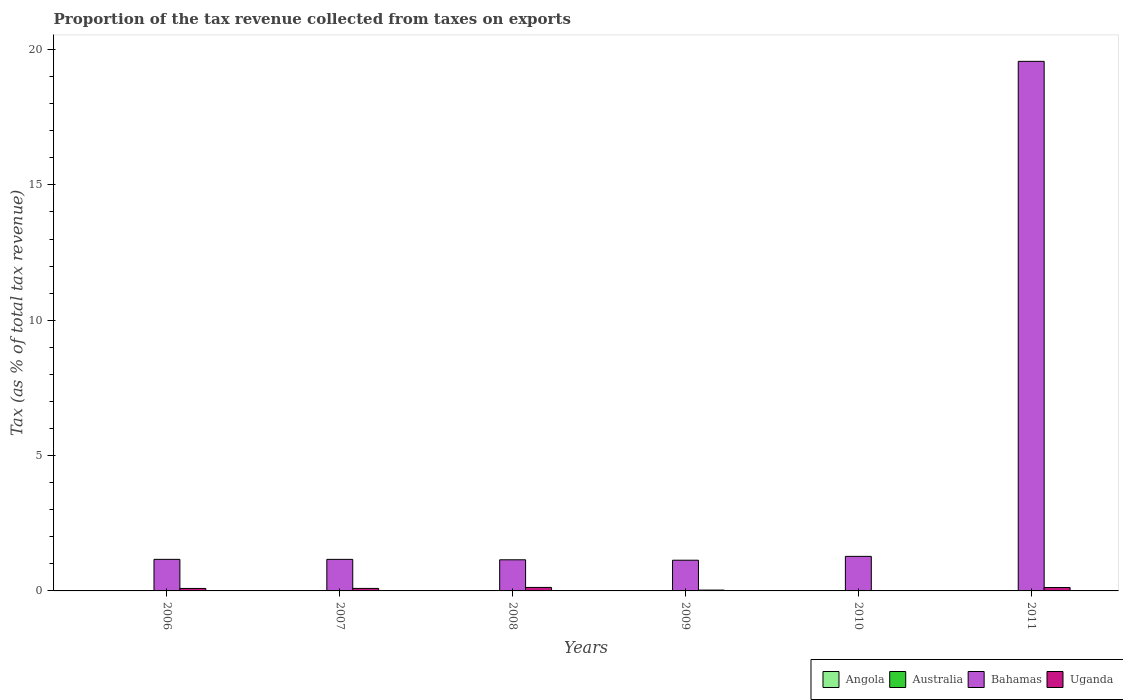Are the number of bars on each tick of the X-axis equal?
Give a very brief answer. Yes. How many bars are there on the 1st tick from the right?
Your answer should be very brief. 4. What is the label of the 3rd group of bars from the left?
Offer a very short reply. 2008. What is the proportion of the tax revenue collected in Bahamas in 2009?
Offer a terse response. 1.13. Across all years, what is the maximum proportion of the tax revenue collected in Angola?
Your response must be concise. 0.01. Across all years, what is the minimum proportion of the tax revenue collected in Angola?
Your answer should be very brief. 0. In which year was the proportion of the tax revenue collected in Uganda maximum?
Keep it short and to the point. 2008. What is the total proportion of the tax revenue collected in Angola in the graph?
Make the answer very short. 0.02. What is the difference between the proportion of the tax revenue collected in Angola in 2010 and that in 2011?
Ensure brevity in your answer.  0. What is the difference between the proportion of the tax revenue collected in Bahamas in 2008 and the proportion of the tax revenue collected in Angola in 2007?
Make the answer very short. 1.14. What is the average proportion of the tax revenue collected in Angola per year?
Your response must be concise. 0. In the year 2009, what is the difference between the proportion of the tax revenue collected in Angola and proportion of the tax revenue collected in Bahamas?
Offer a terse response. -1.13. In how many years, is the proportion of the tax revenue collected in Angola greater than 1 %?
Provide a short and direct response. 0. What is the ratio of the proportion of the tax revenue collected in Australia in 2007 to that in 2009?
Provide a short and direct response. 1.14. Is the proportion of the tax revenue collected in Bahamas in 2010 less than that in 2011?
Offer a very short reply. Yes. What is the difference between the highest and the second highest proportion of the tax revenue collected in Bahamas?
Give a very brief answer. 18.29. What is the difference between the highest and the lowest proportion of the tax revenue collected in Bahamas?
Provide a short and direct response. 18.43. What does the 1st bar from the left in 2010 represents?
Offer a very short reply. Angola. What does the 2nd bar from the right in 2011 represents?
Offer a very short reply. Bahamas. Is it the case that in every year, the sum of the proportion of the tax revenue collected in Uganda and proportion of the tax revenue collected in Australia is greater than the proportion of the tax revenue collected in Angola?
Provide a short and direct response. Yes. Are all the bars in the graph horizontal?
Your answer should be very brief. No. How many years are there in the graph?
Your answer should be compact. 6. What is the difference between two consecutive major ticks on the Y-axis?
Keep it short and to the point. 5. Does the graph contain grids?
Ensure brevity in your answer.  No. Where does the legend appear in the graph?
Provide a short and direct response. Bottom right. How are the legend labels stacked?
Keep it short and to the point. Horizontal. What is the title of the graph?
Keep it short and to the point. Proportion of the tax revenue collected from taxes on exports. What is the label or title of the Y-axis?
Ensure brevity in your answer.  Tax (as % of total tax revenue). What is the Tax (as % of total tax revenue) in Angola in 2006?
Offer a very short reply. 0.01. What is the Tax (as % of total tax revenue) of Australia in 2006?
Your answer should be compact. 0.01. What is the Tax (as % of total tax revenue) of Bahamas in 2006?
Give a very brief answer. 1.17. What is the Tax (as % of total tax revenue) in Uganda in 2006?
Give a very brief answer. 0.09. What is the Tax (as % of total tax revenue) of Angola in 2007?
Ensure brevity in your answer.  0.01. What is the Tax (as % of total tax revenue) in Australia in 2007?
Provide a short and direct response. 0.01. What is the Tax (as % of total tax revenue) in Bahamas in 2007?
Give a very brief answer. 1.17. What is the Tax (as % of total tax revenue) of Uganda in 2007?
Provide a short and direct response. 0.09. What is the Tax (as % of total tax revenue) in Angola in 2008?
Keep it short and to the point. 0. What is the Tax (as % of total tax revenue) in Australia in 2008?
Keep it short and to the point. 0. What is the Tax (as % of total tax revenue) in Bahamas in 2008?
Your response must be concise. 1.15. What is the Tax (as % of total tax revenue) of Uganda in 2008?
Keep it short and to the point. 0.13. What is the Tax (as % of total tax revenue) of Angola in 2009?
Provide a short and direct response. 0. What is the Tax (as % of total tax revenue) of Australia in 2009?
Keep it short and to the point. 0. What is the Tax (as % of total tax revenue) in Bahamas in 2009?
Provide a short and direct response. 1.13. What is the Tax (as % of total tax revenue) of Uganda in 2009?
Give a very brief answer. 0.03. What is the Tax (as % of total tax revenue) of Angola in 2010?
Offer a very short reply. 0. What is the Tax (as % of total tax revenue) of Australia in 2010?
Give a very brief answer. 0.01. What is the Tax (as % of total tax revenue) in Bahamas in 2010?
Provide a succinct answer. 1.28. What is the Tax (as % of total tax revenue) of Uganda in 2010?
Provide a succinct answer. 0. What is the Tax (as % of total tax revenue) in Angola in 2011?
Provide a short and direct response. 0. What is the Tax (as % of total tax revenue) in Australia in 2011?
Provide a succinct answer. 0. What is the Tax (as % of total tax revenue) of Bahamas in 2011?
Keep it short and to the point. 19.56. What is the Tax (as % of total tax revenue) in Uganda in 2011?
Provide a short and direct response. 0.13. Across all years, what is the maximum Tax (as % of total tax revenue) of Angola?
Your answer should be compact. 0.01. Across all years, what is the maximum Tax (as % of total tax revenue) in Australia?
Your response must be concise. 0.01. Across all years, what is the maximum Tax (as % of total tax revenue) in Bahamas?
Give a very brief answer. 19.56. Across all years, what is the maximum Tax (as % of total tax revenue) in Uganda?
Offer a terse response. 0.13. Across all years, what is the minimum Tax (as % of total tax revenue) in Angola?
Give a very brief answer. 0. Across all years, what is the minimum Tax (as % of total tax revenue) in Australia?
Provide a short and direct response. 0. Across all years, what is the minimum Tax (as % of total tax revenue) of Bahamas?
Make the answer very short. 1.13. Across all years, what is the minimum Tax (as % of total tax revenue) in Uganda?
Offer a terse response. 0. What is the total Tax (as % of total tax revenue) in Angola in the graph?
Your answer should be very brief. 0.02. What is the total Tax (as % of total tax revenue) of Australia in the graph?
Give a very brief answer. 0.03. What is the total Tax (as % of total tax revenue) of Bahamas in the graph?
Your response must be concise. 25.46. What is the total Tax (as % of total tax revenue) in Uganda in the graph?
Offer a terse response. 0.47. What is the difference between the Tax (as % of total tax revenue) in Angola in 2006 and that in 2007?
Offer a very short reply. 0. What is the difference between the Tax (as % of total tax revenue) in Uganda in 2006 and that in 2007?
Offer a very short reply. -0. What is the difference between the Tax (as % of total tax revenue) of Angola in 2006 and that in 2008?
Ensure brevity in your answer.  0.01. What is the difference between the Tax (as % of total tax revenue) in Australia in 2006 and that in 2008?
Your response must be concise. 0. What is the difference between the Tax (as % of total tax revenue) in Bahamas in 2006 and that in 2008?
Your answer should be very brief. 0.02. What is the difference between the Tax (as % of total tax revenue) in Uganda in 2006 and that in 2008?
Offer a very short reply. -0.04. What is the difference between the Tax (as % of total tax revenue) of Angola in 2006 and that in 2009?
Make the answer very short. 0.01. What is the difference between the Tax (as % of total tax revenue) in Australia in 2006 and that in 2009?
Offer a terse response. 0. What is the difference between the Tax (as % of total tax revenue) in Bahamas in 2006 and that in 2009?
Your answer should be compact. 0.03. What is the difference between the Tax (as % of total tax revenue) of Uganda in 2006 and that in 2009?
Your answer should be very brief. 0.06. What is the difference between the Tax (as % of total tax revenue) in Angola in 2006 and that in 2010?
Your answer should be very brief. 0.01. What is the difference between the Tax (as % of total tax revenue) in Bahamas in 2006 and that in 2010?
Offer a very short reply. -0.11. What is the difference between the Tax (as % of total tax revenue) of Uganda in 2006 and that in 2010?
Provide a succinct answer. 0.09. What is the difference between the Tax (as % of total tax revenue) in Angola in 2006 and that in 2011?
Keep it short and to the point. 0.01. What is the difference between the Tax (as % of total tax revenue) of Australia in 2006 and that in 2011?
Provide a succinct answer. 0. What is the difference between the Tax (as % of total tax revenue) in Bahamas in 2006 and that in 2011?
Your response must be concise. -18.4. What is the difference between the Tax (as % of total tax revenue) of Uganda in 2006 and that in 2011?
Provide a short and direct response. -0.03. What is the difference between the Tax (as % of total tax revenue) in Angola in 2007 and that in 2008?
Your response must be concise. 0.01. What is the difference between the Tax (as % of total tax revenue) of Australia in 2007 and that in 2008?
Your response must be concise. 0. What is the difference between the Tax (as % of total tax revenue) in Bahamas in 2007 and that in 2008?
Make the answer very short. 0.02. What is the difference between the Tax (as % of total tax revenue) of Uganda in 2007 and that in 2008?
Your answer should be compact. -0.04. What is the difference between the Tax (as % of total tax revenue) of Angola in 2007 and that in 2009?
Make the answer very short. 0.01. What is the difference between the Tax (as % of total tax revenue) of Australia in 2007 and that in 2009?
Give a very brief answer. 0. What is the difference between the Tax (as % of total tax revenue) of Bahamas in 2007 and that in 2009?
Your answer should be very brief. 0.03. What is the difference between the Tax (as % of total tax revenue) of Uganda in 2007 and that in 2009?
Provide a short and direct response. 0.06. What is the difference between the Tax (as % of total tax revenue) of Angola in 2007 and that in 2010?
Give a very brief answer. 0.01. What is the difference between the Tax (as % of total tax revenue) in Bahamas in 2007 and that in 2010?
Ensure brevity in your answer.  -0.11. What is the difference between the Tax (as % of total tax revenue) in Uganda in 2007 and that in 2010?
Your answer should be compact. 0.09. What is the difference between the Tax (as % of total tax revenue) of Angola in 2007 and that in 2011?
Give a very brief answer. 0.01. What is the difference between the Tax (as % of total tax revenue) of Australia in 2007 and that in 2011?
Your response must be concise. 0. What is the difference between the Tax (as % of total tax revenue) of Bahamas in 2007 and that in 2011?
Make the answer very short. -18.4. What is the difference between the Tax (as % of total tax revenue) in Uganda in 2007 and that in 2011?
Make the answer very short. -0.03. What is the difference between the Tax (as % of total tax revenue) in Angola in 2008 and that in 2009?
Offer a terse response. -0. What is the difference between the Tax (as % of total tax revenue) in Australia in 2008 and that in 2009?
Make the answer very short. -0. What is the difference between the Tax (as % of total tax revenue) in Bahamas in 2008 and that in 2009?
Your response must be concise. 0.02. What is the difference between the Tax (as % of total tax revenue) of Uganda in 2008 and that in 2009?
Provide a succinct answer. 0.1. What is the difference between the Tax (as % of total tax revenue) of Angola in 2008 and that in 2010?
Offer a terse response. -0. What is the difference between the Tax (as % of total tax revenue) of Australia in 2008 and that in 2010?
Make the answer very short. -0. What is the difference between the Tax (as % of total tax revenue) in Bahamas in 2008 and that in 2010?
Offer a very short reply. -0.13. What is the difference between the Tax (as % of total tax revenue) in Uganda in 2008 and that in 2010?
Provide a short and direct response. 0.13. What is the difference between the Tax (as % of total tax revenue) of Angola in 2008 and that in 2011?
Ensure brevity in your answer.  -0. What is the difference between the Tax (as % of total tax revenue) in Australia in 2008 and that in 2011?
Offer a very short reply. -0. What is the difference between the Tax (as % of total tax revenue) in Bahamas in 2008 and that in 2011?
Offer a terse response. -18.41. What is the difference between the Tax (as % of total tax revenue) in Uganda in 2008 and that in 2011?
Your response must be concise. 0. What is the difference between the Tax (as % of total tax revenue) of Angola in 2009 and that in 2010?
Your response must be concise. -0. What is the difference between the Tax (as % of total tax revenue) in Australia in 2009 and that in 2010?
Keep it short and to the point. -0. What is the difference between the Tax (as % of total tax revenue) in Bahamas in 2009 and that in 2010?
Provide a short and direct response. -0.14. What is the difference between the Tax (as % of total tax revenue) of Uganda in 2009 and that in 2010?
Your answer should be compact. 0.03. What is the difference between the Tax (as % of total tax revenue) in Angola in 2009 and that in 2011?
Make the answer very short. 0. What is the difference between the Tax (as % of total tax revenue) of Australia in 2009 and that in 2011?
Offer a terse response. 0. What is the difference between the Tax (as % of total tax revenue) of Bahamas in 2009 and that in 2011?
Ensure brevity in your answer.  -18.43. What is the difference between the Tax (as % of total tax revenue) of Uganda in 2009 and that in 2011?
Your answer should be compact. -0.09. What is the difference between the Tax (as % of total tax revenue) of Australia in 2010 and that in 2011?
Your answer should be very brief. 0. What is the difference between the Tax (as % of total tax revenue) of Bahamas in 2010 and that in 2011?
Give a very brief answer. -18.29. What is the difference between the Tax (as % of total tax revenue) in Uganda in 2010 and that in 2011?
Ensure brevity in your answer.  -0.12. What is the difference between the Tax (as % of total tax revenue) in Angola in 2006 and the Tax (as % of total tax revenue) in Australia in 2007?
Provide a short and direct response. 0. What is the difference between the Tax (as % of total tax revenue) in Angola in 2006 and the Tax (as % of total tax revenue) in Bahamas in 2007?
Make the answer very short. -1.16. What is the difference between the Tax (as % of total tax revenue) of Angola in 2006 and the Tax (as % of total tax revenue) of Uganda in 2007?
Provide a short and direct response. -0.09. What is the difference between the Tax (as % of total tax revenue) in Australia in 2006 and the Tax (as % of total tax revenue) in Bahamas in 2007?
Keep it short and to the point. -1.16. What is the difference between the Tax (as % of total tax revenue) in Australia in 2006 and the Tax (as % of total tax revenue) in Uganda in 2007?
Your response must be concise. -0.09. What is the difference between the Tax (as % of total tax revenue) of Bahamas in 2006 and the Tax (as % of total tax revenue) of Uganda in 2007?
Provide a succinct answer. 1.07. What is the difference between the Tax (as % of total tax revenue) of Angola in 2006 and the Tax (as % of total tax revenue) of Australia in 2008?
Keep it short and to the point. 0. What is the difference between the Tax (as % of total tax revenue) in Angola in 2006 and the Tax (as % of total tax revenue) in Bahamas in 2008?
Provide a succinct answer. -1.14. What is the difference between the Tax (as % of total tax revenue) of Angola in 2006 and the Tax (as % of total tax revenue) of Uganda in 2008?
Your answer should be compact. -0.12. What is the difference between the Tax (as % of total tax revenue) in Australia in 2006 and the Tax (as % of total tax revenue) in Bahamas in 2008?
Your answer should be very brief. -1.14. What is the difference between the Tax (as % of total tax revenue) in Australia in 2006 and the Tax (as % of total tax revenue) in Uganda in 2008?
Offer a terse response. -0.12. What is the difference between the Tax (as % of total tax revenue) of Bahamas in 2006 and the Tax (as % of total tax revenue) of Uganda in 2008?
Keep it short and to the point. 1.04. What is the difference between the Tax (as % of total tax revenue) of Angola in 2006 and the Tax (as % of total tax revenue) of Australia in 2009?
Provide a short and direct response. 0. What is the difference between the Tax (as % of total tax revenue) of Angola in 2006 and the Tax (as % of total tax revenue) of Bahamas in 2009?
Provide a succinct answer. -1.13. What is the difference between the Tax (as % of total tax revenue) of Angola in 2006 and the Tax (as % of total tax revenue) of Uganda in 2009?
Offer a very short reply. -0.02. What is the difference between the Tax (as % of total tax revenue) in Australia in 2006 and the Tax (as % of total tax revenue) in Bahamas in 2009?
Provide a succinct answer. -1.13. What is the difference between the Tax (as % of total tax revenue) of Australia in 2006 and the Tax (as % of total tax revenue) of Uganda in 2009?
Your answer should be compact. -0.03. What is the difference between the Tax (as % of total tax revenue) of Bahamas in 2006 and the Tax (as % of total tax revenue) of Uganda in 2009?
Your answer should be very brief. 1.14. What is the difference between the Tax (as % of total tax revenue) in Angola in 2006 and the Tax (as % of total tax revenue) in Australia in 2010?
Make the answer very short. 0. What is the difference between the Tax (as % of total tax revenue) in Angola in 2006 and the Tax (as % of total tax revenue) in Bahamas in 2010?
Keep it short and to the point. -1.27. What is the difference between the Tax (as % of total tax revenue) of Angola in 2006 and the Tax (as % of total tax revenue) of Uganda in 2010?
Your response must be concise. 0. What is the difference between the Tax (as % of total tax revenue) of Australia in 2006 and the Tax (as % of total tax revenue) of Bahamas in 2010?
Offer a terse response. -1.27. What is the difference between the Tax (as % of total tax revenue) in Australia in 2006 and the Tax (as % of total tax revenue) in Uganda in 2010?
Your answer should be very brief. 0. What is the difference between the Tax (as % of total tax revenue) in Bahamas in 2006 and the Tax (as % of total tax revenue) in Uganda in 2010?
Your answer should be very brief. 1.16. What is the difference between the Tax (as % of total tax revenue) of Angola in 2006 and the Tax (as % of total tax revenue) of Australia in 2011?
Offer a very short reply. 0. What is the difference between the Tax (as % of total tax revenue) of Angola in 2006 and the Tax (as % of total tax revenue) of Bahamas in 2011?
Offer a terse response. -19.56. What is the difference between the Tax (as % of total tax revenue) in Angola in 2006 and the Tax (as % of total tax revenue) in Uganda in 2011?
Provide a succinct answer. -0.12. What is the difference between the Tax (as % of total tax revenue) of Australia in 2006 and the Tax (as % of total tax revenue) of Bahamas in 2011?
Provide a succinct answer. -19.56. What is the difference between the Tax (as % of total tax revenue) of Australia in 2006 and the Tax (as % of total tax revenue) of Uganda in 2011?
Provide a succinct answer. -0.12. What is the difference between the Tax (as % of total tax revenue) in Bahamas in 2006 and the Tax (as % of total tax revenue) in Uganda in 2011?
Offer a terse response. 1.04. What is the difference between the Tax (as % of total tax revenue) in Angola in 2007 and the Tax (as % of total tax revenue) in Australia in 2008?
Provide a short and direct response. 0. What is the difference between the Tax (as % of total tax revenue) of Angola in 2007 and the Tax (as % of total tax revenue) of Bahamas in 2008?
Keep it short and to the point. -1.14. What is the difference between the Tax (as % of total tax revenue) of Angola in 2007 and the Tax (as % of total tax revenue) of Uganda in 2008?
Provide a short and direct response. -0.12. What is the difference between the Tax (as % of total tax revenue) of Australia in 2007 and the Tax (as % of total tax revenue) of Bahamas in 2008?
Offer a very short reply. -1.14. What is the difference between the Tax (as % of total tax revenue) of Australia in 2007 and the Tax (as % of total tax revenue) of Uganda in 2008?
Provide a short and direct response. -0.12. What is the difference between the Tax (as % of total tax revenue) in Bahamas in 2007 and the Tax (as % of total tax revenue) in Uganda in 2008?
Make the answer very short. 1.04. What is the difference between the Tax (as % of total tax revenue) of Angola in 2007 and the Tax (as % of total tax revenue) of Australia in 2009?
Offer a very short reply. 0. What is the difference between the Tax (as % of total tax revenue) in Angola in 2007 and the Tax (as % of total tax revenue) in Bahamas in 2009?
Offer a terse response. -1.13. What is the difference between the Tax (as % of total tax revenue) in Angola in 2007 and the Tax (as % of total tax revenue) in Uganda in 2009?
Provide a short and direct response. -0.03. What is the difference between the Tax (as % of total tax revenue) in Australia in 2007 and the Tax (as % of total tax revenue) in Bahamas in 2009?
Make the answer very short. -1.13. What is the difference between the Tax (as % of total tax revenue) in Australia in 2007 and the Tax (as % of total tax revenue) in Uganda in 2009?
Keep it short and to the point. -0.03. What is the difference between the Tax (as % of total tax revenue) in Bahamas in 2007 and the Tax (as % of total tax revenue) in Uganda in 2009?
Keep it short and to the point. 1.13. What is the difference between the Tax (as % of total tax revenue) in Angola in 2007 and the Tax (as % of total tax revenue) in Australia in 2010?
Your answer should be compact. 0. What is the difference between the Tax (as % of total tax revenue) of Angola in 2007 and the Tax (as % of total tax revenue) of Bahamas in 2010?
Offer a very short reply. -1.27. What is the difference between the Tax (as % of total tax revenue) of Angola in 2007 and the Tax (as % of total tax revenue) of Uganda in 2010?
Keep it short and to the point. 0. What is the difference between the Tax (as % of total tax revenue) in Australia in 2007 and the Tax (as % of total tax revenue) in Bahamas in 2010?
Make the answer very short. -1.27. What is the difference between the Tax (as % of total tax revenue) of Australia in 2007 and the Tax (as % of total tax revenue) of Uganda in 2010?
Keep it short and to the point. 0. What is the difference between the Tax (as % of total tax revenue) of Bahamas in 2007 and the Tax (as % of total tax revenue) of Uganda in 2010?
Offer a very short reply. 1.16. What is the difference between the Tax (as % of total tax revenue) of Angola in 2007 and the Tax (as % of total tax revenue) of Australia in 2011?
Provide a succinct answer. 0. What is the difference between the Tax (as % of total tax revenue) of Angola in 2007 and the Tax (as % of total tax revenue) of Bahamas in 2011?
Ensure brevity in your answer.  -19.56. What is the difference between the Tax (as % of total tax revenue) of Angola in 2007 and the Tax (as % of total tax revenue) of Uganda in 2011?
Offer a very short reply. -0.12. What is the difference between the Tax (as % of total tax revenue) of Australia in 2007 and the Tax (as % of total tax revenue) of Bahamas in 2011?
Give a very brief answer. -19.56. What is the difference between the Tax (as % of total tax revenue) in Australia in 2007 and the Tax (as % of total tax revenue) in Uganda in 2011?
Your answer should be very brief. -0.12. What is the difference between the Tax (as % of total tax revenue) in Bahamas in 2007 and the Tax (as % of total tax revenue) in Uganda in 2011?
Your answer should be compact. 1.04. What is the difference between the Tax (as % of total tax revenue) in Angola in 2008 and the Tax (as % of total tax revenue) in Australia in 2009?
Make the answer very short. -0. What is the difference between the Tax (as % of total tax revenue) in Angola in 2008 and the Tax (as % of total tax revenue) in Bahamas in 2009?
Your answer should be very brief. -1.13. What is the difference between the Tax (as % of total tax revenue) of Angola in 2008 and the Tax (as % of total tax revenue) of Uganda in 2009?
Make the answer very short. -0.03. What is the difference between the Tax (as % of total tax revenue) of Australia in 2008 and the Tax (as % of total tax revenue) of Bahamas in 2009?
Your response must be concise. -1.13. What is the difference between the Tax (as % of total tax revenue) in Australia in 2008 and the Tax (as % of total tax revenue) in Uganda in 2009?
Keep it short and to the point. -0.03. What is the difference between the Tax (as % of total tax revenue) of Bahamas in 2008 and the Tax (as % of total tax revenue) of Uganda in 2009?
Keep it short and to the point. 1.12. What is the difference between the Tax (as % of total tax revenue) of Angola in 2008 and the Tax (as % of total tax revenue) of Australia in 2010?
Make the answer very short. -0. What is the difference between the Tax (as % of total tax revenue) in Angola in 2008 and the Tax (as % of total tax revenue) in Bahamas in 2010?
Your answer should be compact. -1.28. What is the difference between the Tax (as % of total tax revenue) in Angola in 2008 and the Tax (as % of total tax revenue) in Uganda in 2010?
Your response must be concise. -0. What is the difference between the Tax (as % of total tax revenue) in Australia in 2008 and the Tax (as % of total tax revenue) in Bahamas in 2010?
Give a very brief answer. -1.27. What is the difference between the Tax (as % of total tax revenue) of Australia in 2008 and the Tax (as % of total tax revenue) of Uganda in 2010?
Your response must be concise. 0. What is the difference between the Tax (as % of total tax revenue) of Bahamas in 2008 and the Tax (as % of total tax revenue) of Uganda in 2010?
Ensure brevity in your answer.  1.15. What is the difference between the Tax (as % of total tax revenue) of Angola in 2008 and the Tax (as % of total tax revenue) of Australia in 2011?
Provide a short and direct response. -0. What is the difference between the Tax (as % of total tax revenue) of Angola in 2008 and the Tax (as % of total tax revenue) of Bahamas in 2011?
Give a very brief answer. -19.56. What is the difference between the Tax (as % of total tax revenue) of Angola in 2008 and the Tax (as % of total tax revenue) of Uganda in 2011?
Offer a very short reply. -0.13. What is the difference between the Tax (as % of total tax revenue) of Australia in 2008 and the Tax (as % of total tax revenue) of Bahamas in 2011?
Provide a short and direct response. -19.56. What is the difference between the Tax (as % of total tax revenue) of Australia in 2008 and the Tax (as % of total tax revenue) of Uganda in 2011?
Provide a succinct answer. -0.12. What is the difference between the Tax (as % of total tax revenue) in Bahamas in 2008 and the Tax (as % of total tax revenue) in Uganda in 2011?
Offer a terse response. 1.02. What is the difference between the Tax (as % of total tax revenue) in Angola in 2009 and the Tax (as % of total tax revenue) in Australia in 2010?
Your answer should be compact. -0. What is the difference between the Tax (as % of total tax revenue) in Angola in 2009 and the Tax (as % of total tax revenue) in Bahamas in 2010?
Make the answer very short. -1.28. What is the difference between the Tax (as % of total tax revenue) of Angola in 2009 and the Tax (as % of total tax revenue) of Uganda in 2010?
Keep it short and to the point. -0. What is the difference between the Tax (as % of total tax revenue) of Australia in 2009 and the Tax (as % of total tax revenue) of Bahamas in 2010?
Keep it short and to the point. -1.27. What is the difference between the Tax (as % of total tax revenue) in Australia in 2009 and the Tax (as % of total tax revenue) in Uganda in 2010?
Make the answer very short. 0. What is the difference between the Tax (as % of total tax revenue) of Bahamas in 2009 and the Tax (as % of total tax revenue) of Uganda in 2010?
Make the answer very short. 1.13. What is the difference between the Tax (as % of total tax revenue) in Angola in 2009 and the Tax (as % of total tax revenue) in Australia in 2011?
Offer a very short reply. -0. What is the difference between the Tax (as % of total tax revenue) of Angola in 2009 and the Tax (as % of total tax revenue) of Bahamas in 2011?
Your response must be concise. -19.56. What is the difference between the Tax (as % of total tax revenue) in Angola in 2009 and the Tax (as % of total tax revenue) in Uganda in 2011?
Your response must be concise. -0.13. What is the difference between the Tax (as % of total tax revenue) of Australia in 2009 and the Tax (as % of total tax revenue) of Bahamas in 2011?
Provide a succinct answer. -19.56. What is the difference between the Tax (as % of total tax revenue) of Australia in 2009 and the Tax (as % of total tax revenue) of Uganda in 2011?
Provide a short and direct response. -0.12. What is the difference between the Tax (as % of total tax revenue) in Bahamas in 2009 and the Tax (as % of total tax revenue) in Uganda in 2011?
Provide a short and direct response. 1.01. What is the difference between the Tax (as % of total tax revenue) in Angola in 2010 and the Tax (as % of total tax revenue) in Australia in 2011?
Give a very brief answer. -0. What is the difference between the Tax (as % of total tax revenue) in Angola in 2010 and the Tax (as % of total tax revenue) in Bahamas in 2011?
Keep it short and to the point. -19.56. What is the difference between the Tax (as % of total tax revenue) in Angola in 2010 and the Tax (as % of total tax revenue) in Uganda in 2011?
Make the answer very short. -0.12. What is the difference between the Tax (as % of total tax revenue) in Australia in 2010 and the Tax (as % of total tax revenue) in Bahamas in 2011?
Your answer should be very brief. -19.56. What is the difference between the Tax (as % of total tax revenue) of Australia in 2010 and the Tax (as % of total tax revenue) of Uganda in 2011?
Give a very brief answer. -0.12. What is the difference between the Tax (as % of total tax revenue) in Bahamas in 2010 and the Tax (as % of total tax revenue) in Uganda in 2011?
Offer a very short reply. 1.15. What is the average Tax (as % of total tax revenue) of Angola per year?
Keep it short and to the point. 0. What is the average Tax (as % of total tax revenue) of Australia per year?
Your answer should be very brief. 0. What is the average Tax (as % of total tax revenue) in Bahamas per year?
Keep it short and to the point. 4.24. What is the average Tax (as % of total tax revenue) of Uganda per year?
Your response must be concise. 0.08. In the year 2006, what is the difference between the Tax (as % of total tax revenue) in Angola and Tax (as % of total tax revenue) in Australia?
Keep it short and to the point. 0. In the year 2006, what is the difference between the Tax (as % of total tax revenue) in Angola and Tax (as % of total tax revenue) in Bahamas?
Your answer should be very brief. -1.16. In the year 2006, what is the difference between the Tax (as % of total tax revenue) in Angola and Tax (as % of total tax revenue) in Uganda?
Give a very brief answer. -0.08. In the year 2006, what is the difference between the Tax (as % of total tax revenue) in Australia and Tax (as % of total tax revenue) in Bahamas?
Give a very brief answer. -1.16. In the year 2006, what is the difference between the Tax (as % of total tax revenue) of Australia and Tax (as % of total tax revenue) of Uganda?
Your response must be concise. -0.09. In the year 2006, what is the difference between the Tax (as % of total tax revenue) of Bahamas and Tax (as % of total tax revenue) of Uganda?
Your answer should be compact. 1.07. In the year 2007, what is the difference between the Tax (as % of total tax revenue) in Angola and Tax (as % of total tax revenue) in Australia?
Your answer should be very brief. 0. In the year 2007, what is the difference between the Tax (as % of total tax revenue) in Angola and Tax (as % of total tax revenue) in Bahamas?
Your answer should be very brief. -1.16. In the year 2007, what is the difference between the Tax (as % of total tax revenue) in Angola and Tax (as % of total tax revenue) in Uganda?
Your answer should be very brief. -0.09. In the year 2007, what is the difference between the Tax (as % of total tax revenue) of Australia and Tax (as % of total tax revenue) of Bahamas?
Ensure brevity in your answer.  -1.16. In the year 2007, what is the difference between the Tax (as % of total tax revenue) of Australia and Tax (as % of total tax revenue) of Uganda?
Your answer should be very brief. -0.09. In the year 2007, what is the difference between the Tax (as % of total tax revenue) of Bahamas and Tax (as % of total tax revenue) of Uganda?
Offer a very short reply. 1.07. In the year 2008, what is the difference between the Tax (as % of total tax revenue) in Angola and Tax (as % of total tax revenue) in Australia?
Ensure brevity in your answer.  -0. In the year 2008, what is the difference between the Tax (as % of total tax revenue) of Angola and Tax (as % of total tax revenue) of Bahamas?
Your answer should be compact. -1.15. In the year 2008, what is the difference between the Tax (as % of total tax revenue) in Angola and Tax (as % of total tax revenue) in Uganda?
Keep it short and to the point. -0.13. In the year 2008, what is the difference between the Tax (as % of total tax revenue) in Australia and Tax (as % of total tax revenue) in Bahamas?
Offer a terse response. -1.15. In the year 2008, what is the difference between the Tax (as % of total tax revenue) of Australia and Tax (as % of total tax revenue) of Uganda?
Give a very brief answer. -0.13. In the year 2008, what is the difference between the Tax (as % of total tax revenue) of Bahamas and Tax (as % of total tax revenue) of Uganda?
Provide a short and direct response. 1.02. In the year 2009, what is the difference between the Tax (as % of total tax revenue) of Angola and Tax (as % of total tax revenue) of Australia?
Your response must be concise. -0. In the year 2009, what is the difference between the Tax (as % of total tax revenue) of Angola and Tax (as % of total tax revenue) of Bahamas?
Your answer should be compact. -1.13. In the year 2009, what is the difference between the Tax (as % of total tax revenue) of Angola and Tax (as % of total tax revenue) of Uganda?
Offer a very short reply. -0.03. In the year 2009, what is the difference between the Tax (as % of total tax revenue) of Australia and Tax (as % of total tax revenue) of Bahamas?
Provide a short and direct response. -1.13. In the year 2009, what is the difference between the Tax (as % of total tax revenue) of Australia and Tax (as % of total tax revenue) of Uganda?
Your answer should be compact. -0.03. In the year 2009, what is the difference between the Tax (as % of total tax revenue) of Bahamas and Tax (as % of total tax revenue) of Uganda?
Provide a succinct answer. 1.1. In the year 2010, what is the difference between the Tax (as % of total tax revenue) in Angola and Tax (as % of total tax revenue) in Australia?
Provide a succinct answer. -0. In the year 2010, what is the difference between the Tax (as % of total tax revenue) in Angola and Tax (as % of total tax revenue) in Bahamas?
Offer a very short reply. -1.28. In the year 2010, what is the difference between the Tax (as % of total tax revenue) of Angola and Tax (as % of total tax revenue) of Uganda?
Provide a succinct answer. -0. In the year 2010, what is the difference between the Tax (as % of total tax revenue) of Australia and Tax (as % of total tax revenue) of Bahamas?
Give a very brief answer. -1.27. In the year 2010, what is the difference between the Tax (as % of total tax revenue) in Australia and Tax (as % of total tax revenue) in Uganda?
Ensure brevity in your answer.  0. In the year 2010, what is the difference between the Tax (as % of total tax revenue) in Bahamas and Tax (as % of total tax revenue) in Uganda?
Ensure brevity in your answer.  1.27. In the year 2011, what is the difference between the Tax (as % of total tax revenue) in Angola and Tax (as % of total tax revenue) in Australia?
Offer a very short reply. -0. In the year 2011, what is the difference between the Tax (as % of total tax revenue) of Angola and Tax (as % of total tax revenue) of Bahamas?
Your answer should be very brief. -19.56. In the year 2011, what is the difference between the Tax (as % of total tax revenue) in Angola and Tax (as % of total tax revenue) in Uganda?
Give a very brief answer. -0.13. In the year 2011, what is the difference between the Tax (as % of total tax revenue) of Australia and Tax (as % of total tax revenue) of Bahamas?
Ensure brevity in your answer.  -19.56. In the year 2011, what is the difference between the Tax (as % of total tax revenue) in Australia and Tax (as % of total tax revenue) in Uganda?
Offer a very short reply. -0.12. In the year 2011, what is the difference between the Tax (as % of total tax revenue) in Bahamas and Tax (as % of total tax revenue) in Uganda?
Make the answer very short. 19.44. What is the ratio of the Tax (as % of total tax revenue) of Angola in 2006 to that in 2007?
Provide a succinct answer. 1.25. What is the ratio of the Tax (as % of total tax revenue) in Australia in 2006 to that in 2007?
Make the answer very short. 1.07. What is the ratio of the Tax (as % of total tax revenue) of Bahamas in 2006 to that in 2007?
Your answer should be compact. 1. What is the ratio of the Tax (as % of total tax revenue) of Uganda in 2006 to that in 2007?
Ensure brevity in your answer.  0.99. What is the ratio of the Tax (as % of total tax revenue) of Angola in 2006 to that in 2008?
Give a very brief answer. 14.83. What is the ratio of the Tax (as % of total tax revenue) in Australia in 2006 to that in 2008?
Your answer should be compact. 1.63. What is the ratio of the Tax (as % of total tax revenue) in Bahamas in 2006 to that in 2008?
Make the answer very short. 1.01. What is the ratio of the Tax (as % of total tax revenue) in Uganda in 2006 to that in 2008?
Your response must be concise. 0.71. What is the ratio of the Tax (as % of total tax revenue) in Angola in 2006 to that in 2009?
Your answer should be very brief. 11.85. What is the ratio of the Tax (as % of total tax revenue) in Australia in 2006 to that in 2009?
Offer a very short reply. 1.22. What is the ratio of the Tax (as % of total tax revenue) in Bahamas in 2006 to that in 2009?
Your response must be concise. 1.03. What is the ratio of the Tax (as % of total tax revenue) in Uganda in 2006 to that in 2009?
Make the answer very short. 2.94. What is the ratio of the Tax (as % of total tax revenue) in Angola in 2006 to that in 2010?
Offer a terse response. 10.36. What is the ratio of the Tax (as % of total tax revenue) of Australia in 2006 to that in 2010?
Ensure brevity in your answer.  1.09. What is the ratio of the Tax (as % of total tax revenue) in Bahamas in 2006 to that in 2010?
Give a very brief answer. 0.91. What is the ratio of the Tax (as % of total tax revenue) in Uganda in 2006 to that in 2010?
Your answer should be very brief. 31.54. What is the ratio of the Tax (as % of total tax revenue) of Angola in 2006 to that in 2011?
Your answer should be compact. 13.15. What is the ratio of the Tax (as % of total tax revenue) in Australia in 2006 to that in 2011?
Provide a short and direct response. 1.5. What is the ratio of the Tax (as % of total tax revenue) of Bahamas in 2006 to that in 2011?
Your answer should be compact. 0.06. What is the ratio of the Tax (as % of total tax revenue) of Uganda in 2006 to that in 2011?
Keep it short and to the point. 0.73. What is the ratio of the Tax (as % of total tax revenue) of Angola in 2007 to that in 2008?
Give a very brief answer. 11.89. What is the ratio of the Tax (as % of total tax revenue) in Australia in 2007 to that in 2008?
Offer a terse response. 1.53. What is the ratio of the Tax (as % of total tax revenue) in Bahamas in 2007 to that in 2008?
Your response must be concise. 1.01. What is the ratio of the Tax (as % of total tax revenue) in Uganda in 2007 to that in 2008?
Ensure brevity in your answer.  0.72. What is the ratio of the Tax (as % of total tax revenue) of Angola in 2007 to that in 2009?
Keep it short and to the point. 9.5. What is the ratio of the Tax (as % of total tax revenue) of Australia in 2007 to that in 2009?
Offer a very short reply. 1.14. What is the ratio of the Tax (as % of total tax revenue) of Bahamas in 2007 to that in 2009?
Your answer should be compact. 1.03. What is the ratio of the Tax (as % of total tax revenue) in Uganda in 2007 to that in 2009?
Keep it short and to the point. 2.98. What is the ratio of the Tax (as % of total tax revenue) in Angola in 2007 to that in 2010?
Offer a very short reply. 8.31. What is the ratio of the Tax (as % of total tax revenue) of Australia in 2007 to that in 2010?
Your answer should be very brief. 1.02. What is the ratio of the Tax (as % of total tax revenue) of Bahamas in 2007 to that in 2010?
Your answer should be compact. 0.91. What is the ratio of the Tax (as % of total tax revenue) in Uganda in 2007 to that in 2010?
Keep it short and to the point. 31.99. What is the ratio of the Tax (as % of total tax revenue) in Angola in 2007 to that in 2011?
Provide a short and direct response. 10.54. What is the ratio of the Tax (as % of total tax revenue) in Australia in 2007 to that in 2011?
Provide a succinct answer. 1.4. What is the ratio of the Tax (as % of total tax revenue) of Bahamas in 2007 to that in 2011?
Provide a short and direct response. 0.06. What is the ratio of the Tax (as % of total tax revenue) in Uganda in 2007 to that in 2011?
Provide a short and direct response. 0.74. What is the ratio of the Tax (as % of total tax revenue) in Angola in 2008 to that in 2009?
Make the answer very short. 0.8. What is the ratio of the Tax (as % of total tax revenue) in Australia in 2008 to that in 2009?
Offer a very short reply. 0.75. What is the ratio of the Tax (as % of total tax revenue) of Bahamas in 2008 to that in 2009?
Your response must be concise. 1.01. What is the ratio of the Tax (as % of total tax revenue) in Uganda in 2008 to that in 2009?
Offer a very short reply. 4.15. What is the ratio of the Tax (as % of total tax revenue) of Angola in 2008 to that in 2010?
Offer a very short reply. 0.7. What is the ratio of the Tax (as % of total tax revenue) of Australia in 2008 to that in 2010?
Make the answer very short. 0.67. What is the ratio of the Tax (as % of total tax revenue) in Bahamas in 2008 to that in 2010?
Your response must be concise. 0.9. What is the ratio of the Tax (as % of total tax revenue) in Uganda in 2008 to that in 2010?
Make the answer very short. 44.5. What is the ratio of the Tax (as % of total tax revenue) of Angola in 2008 to that in 2011?
Keep it short and to the point. 0.89. What is the ratio of the Tax (as % of total tax revenue) of Australia in 2008 to that in 2011?
Make the answer very short. 0.92. What is the ratio of the Tax (as % of total tax revenue) in Bahamas in 2008 to that in 2011?
Your answer should be very brief. 0.06. What is the ratio of the Tax (as % of total tax revenue) of Uganda in 2008 to that in 2011?
Make the answer very short. 1.02. What is the ratio of the Tax (as % of total tax revenue) in Angola in 2009 to that in 2010?
Your answer should be compact. 0.87. What is the ratio of the Tax (as % of total tax revenue) of Australia in 2009 to that in 2010?
Offer a very short reply. 0.89. What is the ratio of the Tax (as % of total tax revenue) in Bahamas in 2009 to that in 2010?
Offer a very short reply. 0.89. What is the ratio of the Tax (as % of total tax revenue) of Uganda in 2009 to that in 2010?
Keep it short and to the point. 10.72. What is the ratio of the Tax (as % of total tax revenue) of Angola in 2009 to that in 2011?
Give a very brief answer. 1.11. What is the ratio of the Tax (as % of total tax revenue) of Australia in 2009 to that in 2011?
Provide a succinct answer. 1.22. What is the ratio of the Tax (as % of total tax revenue) of Bahamas in 2009 to that in 2011?
Your answer should be compact. 0.06. What is the ratio of the Tax (as % of total tax revenue) of Uganda in 2009 to that in 2011?
Your answer should be very brief. 0.25. What is the ratio of the Tax (as % of total tax revenue) in Angola in 2010 to that in 2011?
Offer a terse response. 1.27. What is the ratio of the Tax (as % of total tax revenue) in Australia in 2010 to that in 2011?
Your answer should be compact. 1.37. What is the ratio of the Tax (as % of total tax revenue) in Bahamas in 2010 to that in 2011?
Your answer should be very brief. 0.07. What is the ratio of the Tax (as % of total tax revenue) in Uganda in 2010 to that in 2011?
Offer a terse response. 0.02. What is the difference between the highest and the second highest Tax (as % of total tax revenue) of Angola?
Give a very brief answer. 0. What is the difference between the highest and the second highest Tax (as % of total tax revenue) in Bahamas?
Your answer should be very brief. 18.29. What is the difference between the highest and the second highest Tax (as % of total tax revenue) in Uganda?
Your answer should be compact. 0. What is the difference between the highest and the lowest Tax (as % of total tax revenue) in Angola?
Your answer should be very brief. 0.01. What is the difference between the highest and the lowest Tax (as % of total tax revenue) of Australia?
Provide a succinct answer. 0. What is the difference between the highest and the lowest Tax (as % of total tax revenue) in Bahamas?
Your answer should be compact. 18.43. What is the difference between the highest and the lowest Tax (as % of total tax revenue) of Uganda?
Give a very brief answer. 0.13. 